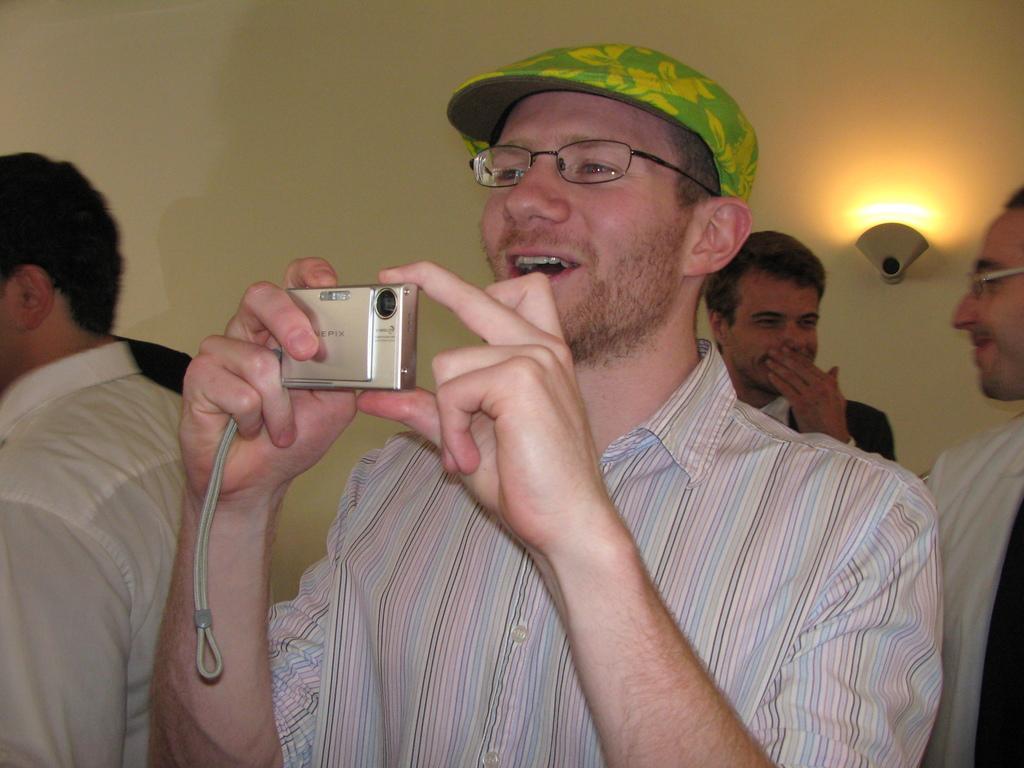In one or two sentences, can you explain what this image depicts? In this image I can see four people standing. Among them one person is wearing the cap and he is taking the pictures with the camera. At the back of them there is a wall and the light. 